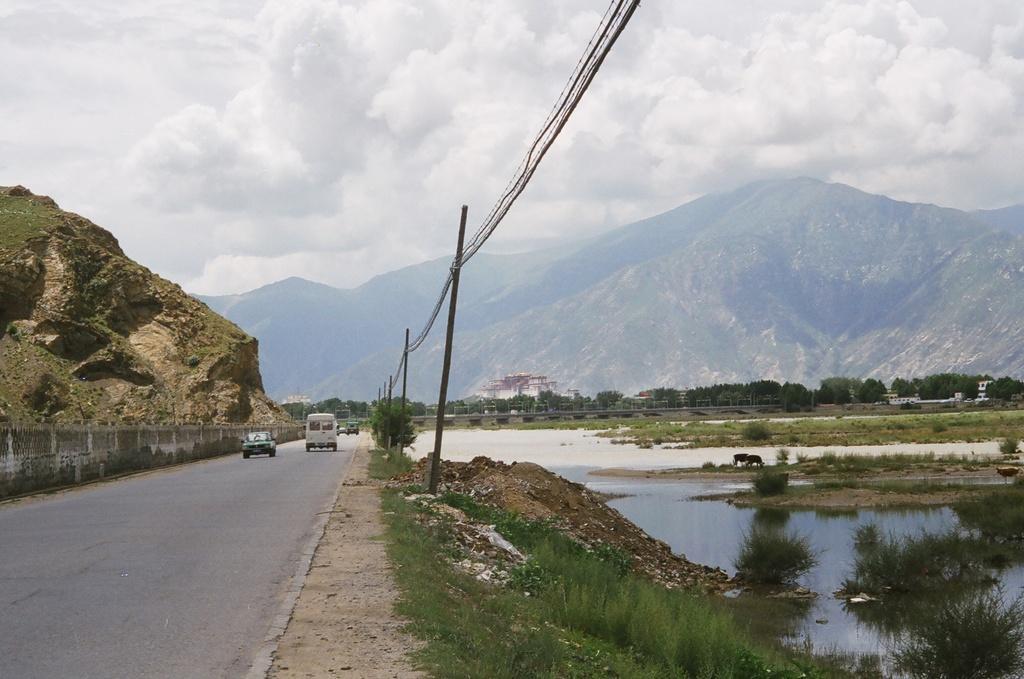Can you describe this image briefly? There are vehicles on the road and this is grass. Here we can see water, poles, trees, and buildings. In the background we can see mountain and sky with clouds. 